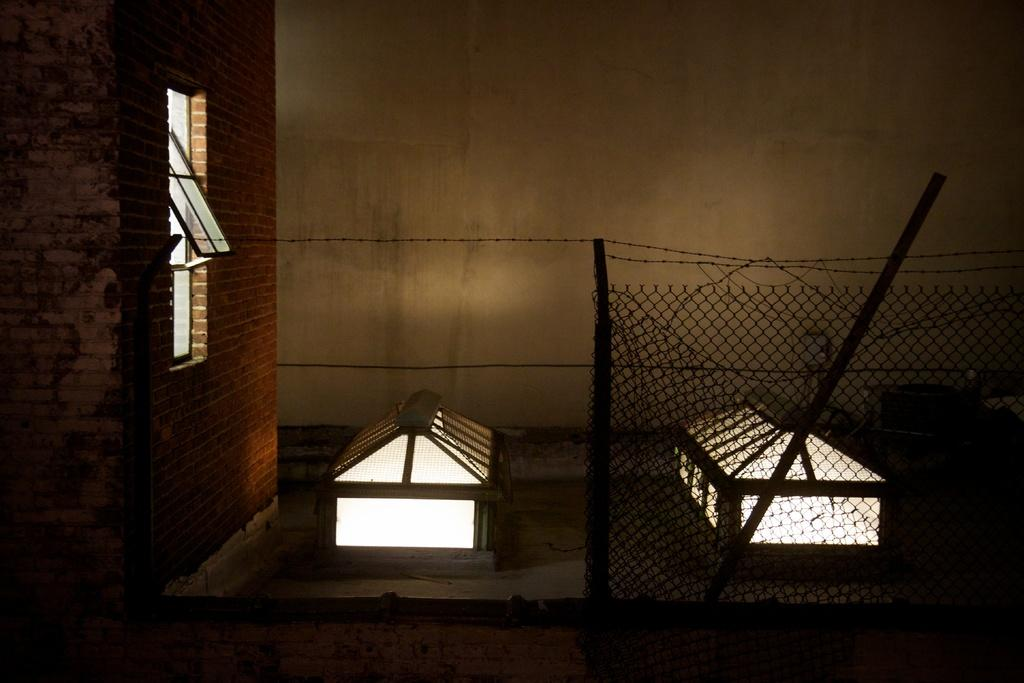What can be seen in the image that allows light to enter a room? There is a window in the image that allows light to enter a room. What is the window connected to? The window is attached to a wall. What is in front of the wall in the image? There is fencing in front of the wall. How many family members are visible in the image? There are no family members visible in the image; it only features a window, a wall, and fencing. 